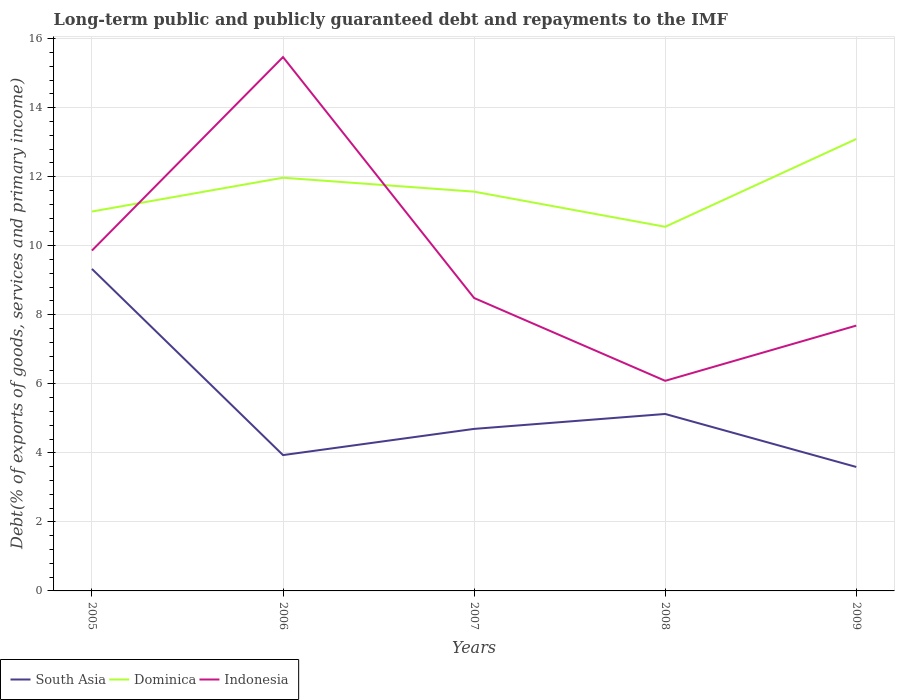How many different coloured lines are there?
Make the answer very short. 3. Does the line corresponding to Dominica intersect with the line corresponding to Indonesia?
Your answer should be compact. Yes. Is the number of lines equal to the number of legend labels?
Your response must be concise. Yes. Across all years, what is the maximum debt and repayments in South Asia?
Keep it short and to the point. 3.59. What is the total debt and repayments in Dominica in the graph?
Keep it short and to the point. -1.12. What is the difference between the highest and the second highest debt and repayments in Indonesia?
Provide a succinct answer. 9.38. How many lines are there?
Your answer should be very brief. 3. How many years are there in the graph?
Give a very brief answer. 5. What is the difference between two consecutive major ticks on the Y-axis?
Your answer should be very brief. 2. Are the values on the major ticks of Y-axis written in scientific E-notation?
Keep it short and to the point. No. How are the legend labels stacked?
Your answer should be very brief. Horizontal. What is the title of the graph?
Provide a short and direct response. Long-term public and publicly guaranteed debt and repayments to the IMF. Does "Chad" appear as one of the legend labels in the graph?
Ensure brevity in your answer.  No. What is the label or title of the X-axis?
Offer a terse response. Years. What is the label or title of the Y-axis?
Provide a short and direct response. Debt(% of exports of goods, services and primary income). What is the Debt(% of exports of goods, services and primary income) of South Asia in 2005?
Offer a terse response. 9.33. What is the Debt(% of exports of goods, services and primary income) in Dominica in 2005?
Offer a very short reply. 10.99. What is the Debt(% of exports of goods, services and primary income) in Indonesia in 2005?
Your answer should be very brief. 9.86. What is the Debt(% of exports of goods, services and primary income) in South Asia in 2006?
Provide a short and direct response. 3.94. What is the Debt(% of exports of goods, services and primary income) of Dominica in 2006?
Provide a succinct answer. 11.97. What is the Debt(% of exports of goods, services and primary income) in Indonesia in 2006?
Give a very brief answer. 15.47. What is the Debt(% of exports of goods, services and primary income) in South Asia in 2007?
Make the answer very short. 4.69. What is the Debt(% of exports of goods, services and primary income) of Dominica in 2007?
Offer a terse response. 11.57. What is the Debt(% of exports of goods, services and primary income) in Indonesia in 2007?
Provide a succinct answer. 8.49. What is the Debt(% of exports of goods, services and primary income) of South Asia in 2008?
Your response must be concise. 5.13. What is the Debt(% of exports of goods, services and primary income) of Dominica in 2008?
Give a very brief answer. 10.55. What is the Debt(% of exports of goods, services and primary income) in Indonesia in 2008?
Make the answer very short. 6.09. What is the Debt(% of exports of goods, services and primary income) of South Asia in 2009?
Make the answer very short. 3.59. What is the Debt(% of exports of goods, services and primary income) of Dominica in 2009?
Provide a succinct answer. 13.09. What is the Debt(% of exports of goods, services and primary income) in Indonesia in 2009?
Offer a very short reply. 7.69. Across all years, what is the maximum Debt(% of exports of goods, services and primary income) in South Asia?
Offer a terse response. 9.33. Across all years, what is the maximum Debt(% of exports of goods, services and primary income) of Dominica?
Provide a succinct answer. 13.09. Across all years, what is the maximum Debt(% of exports of goods, services and primary income) in Indonesia?
Offer a very short reply. 15.47. Across all years, what is the minimum Debt(% of exports of goods, services and primary income) in South Asia?
Offer a terse response. 3.59. Across all years, what is the minimum Debt(% of exports of goods, services and primary income) in Dominica?
Provide a succinct answer. 10.55. Across all years, what is the minimum Debt(% of exports of goods, services and primary income) in Indonesia?
Your response must be concise. 6.09. What is the total Debt(% of exports of goods, services and primary income) in South Asia in the graph?
Offer a terse response. 26.68. What is the total Debt(% of exports of goods, services and primary income) in Dominica in the graph?
Offer a terse response. 58.17. What is the total Debt(% of exports of goods, services and primary income) in Indonesia in the graph?
Offer a terse response. 47.59. What is the difference between the Debt(% of exports of goods, services and primary income) in South Asia in 2005 and that in 2006?
Give a very brief answer. 5.39. What is the difference between the Debt(% of exports of goods, services and primary income) in Dominica in 2005 and that in 2006?
Ensure brevity in your answer.  -0.98. What is the difference between the Debt(% of exports of goods, services and primary income) of Indonesia in 2005 and that in 2006?
Give a very brief answer. -5.61. What is the difference between the Debt(% of exports of goods, services and primary income) of South Asia in 2005 and that in 2007?
Provide a succinct answer. 4.63. What is the difference between the Debt(% of exports of goods, services and primary income) in Dominica in 2005 and that in 2007?
Provide a short and direct response. -0.58. What is the difference between the Debt(% of exports of goods, services and primary income) of Indonesia in 2005 and that in 2007?
Your response must be concise. 1.38. What is the difference between the Debt(% of exports of goods, services and primary income) in South Asia in 2005 and that in 2008?
Provide a short and direct response. 4.2. What is the difference between the Debt(% of exports of goods, services and primary income) in Dominica in 2005 and that in 2008?
Ensure brevity in your answer.  0.44. What is the difference between the Debt(% of exports of goods, services and primary income) of Indonesia in 2005 and that in 2008?
Keep it short and to the point. 3.77. What is the difference between the Debt(% of exports of goods, services and primary income) in South Asia in 2005 and that in 2009?
Your answer should be very brief. 5.74. What is the difference between the Debt(% of exports of goods, services and primary income) in Dominica in 2005 and that in 2009?
Offer a very short reply. -2.1. What is the difference between the Debt(% of exports of goods, services and primary income) of Indonesia in 2005 and that in 2009?
Provide a succinct answer. 2.17. What is the difference between the Debt(% of exports of goods, services and primary income) in South Asia in 2006 and that in 2007?
Make the answer very short. -0.76. What is the difference between the Debt(% of exports of goods, services and primary income) of Dominica in 2006 and that in 2007?
Provide a short and direct response. 0.4. What is the difference between the Debt(% of exports of goods, services and primary income) in Indonesia in 2006 and that in 2007?
Your answer should be compact. 6.98. What is the difference between the Debt(% of exports of goods, services and primary income) of South Asia in 2006 and that in 2008?
Provide a short and direct response. -1.19. What is the difference between the Debt(% of exports of goods, services and primary income) in Dominica in 2006 and that in 2008?
Keep it short and to the point. 1.42. What is the difference between the Debt(% of exports of goods, services and primary income) in Indonesia in 2006 and that in 2008?
Provide a succinct answer. 9.38. What is the difference between the Debt(% of exports of goods, services and primary income) of South Asia in 2006 and that in 2009?
Give a very brief answer. 0.34. What is the difference between the Debt(% of exports of goods, services and primary income) in Dominica in 2006 and that in 2009?
Keep it short and to the point. -1.12. What is the difference between the Debt(% of exports of goods, services and primary income) in Indonesia in 2006 and that in 2009?
Provide a short and direct response. 7.78. What is the difference between the Debt(% of exports of goods, services and primary income) of South Asia in 2007 and that in 2008?
Make the answer very short. -0.43. What is the difference between the Debt(% of exports of goods, services and primary income) of Indonesia in 2007 and that in 2008?
Offer a terse response. 2.4. What is the difference between the Debt(% of exports of goods, services and primary income) in South Asia in 2007 and that in 2009?
Give a very brief answer. 1.1. What is the difference between the Debt(% of exports of goods, services and primary income) in Dominica in 2007 and that in 2009?
Keep it short and to the point. -1.52. What is the difference between the Debt(% of exports of goods, services and primary income) of Indonesia in 2007 and that in 2009?
Provide a succinct answer. 0.8. What is the difference between the Debt(% of exports of goods, services and primary income) of South Asia in 2008 and that in 2009?
Ensure brevity in your answer.  1.53. What is the difference between the Debt(% of exports of goods, services and primary income) in Dominica in 2008 and that in 2009?
Give a very brief answer. -2.54. What is the difference between the Debt(% of exports of goods, services and primary income) of Indonesia in 2008 and that in 2009?
Keep it short and to the point. -1.6. What is the difference between the Debt(% of exports of goods, services and primary income) in South Asia in 2005 and the Debt(% of exports of goods, services and primary income) in Dominica in 2006?
Ensure brevity in your answer.  -2.64. What is the difference between the Debt(% of exports of goods, services and primary income) in South Asia in 2005 and the Debt(% of exports of goods, services and primary income) in Indonesia in 2006?
Provide a short and direct response. -6.14. What is the difference between the Debt(% of exports of goods, services and primary income) in Dominica in 2005 and the Debt(% of exports of goods, services and primary income) in Indonesia in 2006?
Provide a short and direct response. -4.47. What is the difference between the Debt(% of exports of goods, services and primary income) in South Asia in 2005 and the Debt(% of exports of goods, services and primary income) in Dominica in 2007?
Offer a very short reply. -2.24. What is the difference between the Debt(% of exports of goods, services and primary income) in South Asia in 2005 and the Debt(% of exports of goods, services and primary income) in Indonesia in 2007?
Offer a terse response. 0.84. What is the difference between the Debt(% of exports of goods, services and primary income) in Dominica in 2005 and the Debt(% of exports of goods, services and primary income) in Indonesia in 2007?
Give a very brief answer. 2.51. What is the difference between the Debt(% of exports of goods, services and primary income) in South Asia in 2005 and the Debt(% of exports of goods, services and primary income) in Dominica in 2008?
Ensure brevity in your answer.  -1.22. What is the difference between the Debt(% of exports of goods, services and primary income) of South Asia in 2005 and the Debt(% of exports of goods, services and primary income) of Indonesia in 2008?
Give a very brief answer. 3.24. What is the difference between the Debt(% of exports of goods, services and primary income) of Dominica in 2005 and the Debt(% of exports of goods, services and primary income) of Indonesia in 2008?
Provide a short and direct response. 4.9. What is the difference between the Debt(% of exports of goods, services and primary income) of South Asia in 2005 and the Debt(% of exports of goods, services and primary income) of Dominica in 2009?
Keep it short and to the point. -3.76. What is the difference between the Debt(% of exports of goods, services and primary income) in South Asia in 2005 and the Debt(% of exports of goods, services and primary income) in Indonesia in 2009?
Your answer should be very brief. 1.64. What is the difference between the Debt(% of exports of goods, services and primary income) in Dominica in 2005 and the Debt(% of exports of goods, services and primary income) in Indonesia in 2009?
Ensure brevity in your answer.  3.31. What is the difference between the Debt(% of exports of goods, services and primary income) of South Asia in 2006 and the Debt(% of exports of goods, services and primary income) of Dominica in 2007?
Provide a succinct answer. -7.63. What is the difference between the Debt(% of exports of goods, services and primary income) in South Asia in 2006 and the Debt(% of exports of goods, services and primary income) in Indonesia in 2007?
Give a very brief answer. -4.55. What is the difference between the Debt(% of exports of goods, services and primary income) in Dominica in 2006 and the Debt(% of exports of goods, services and primary income) in Indonesia in 2007?
Provide a succinct answer. 3.49. What is the difference between the Debt(% of exports of goods, services and primary income) in South Asia in 2006 and the Debt(% of exports of goods, services and primary income) in Dominica in 2008?
Your answer should be compact. -6.61. What is the difference between the Debt(% of exports of goods, services and primary income) of South Asia in 2006 and the Debt(% of exports of goods, services and primary income) of Indonesia in 2008?
Offer a very short reply. -2.15. What is the difference between the Debt(% of exports of goods, services and primary income) of Dominica in 2006 and the Debt(% of exports of goods, services and primary income) of Indonesia in 2008?
Keep it short and to the point. 5.88. What is the difference between the Debt(% of exports of goods, services and primary income) in South Asia in 2006 and the Debt(% of exports of goods, services and primary income) in Dominica in 2009?
Offer a terse response. -9.16. What is the difference between the Debt(% of exports of goods, services and primary income) in South Asia in 2006 and the Debt(% of exports of goods, services and primary income) in Indonesia in 2009?
Give a very brief answer. -3.75. What is the difference between the Debt(% of exports of goods, services and primary income) of Dominica in 2006 and the Debt(% of exports of goods, services and primary income) of Indonesia in 2009?
Your response must be concise. 4.28. What is the difference between the Debt(% of exports of goods, services and primary income) of South Asia in 2007 and the Debt(% of exports of goods, services and primary income) of Dominica in 2008?
Keep it short and to the point. -5.86. What is the difference between the Debt(% of exports of goods, services and primary income) in South Asia in 2007 and the Debt(% of exports of goods, services and primary income) in Indonesia in 2008?
Your answer should be very brief. -1.39. What is the difference between the Debt(% of exports of goods, services and primary income) in Dominica in 2007 and the Debt(% of exports of goods, services and primary income) in Indonesia in 2008?
Your answer should be very brief. 5.48. What is the difference between the Debt(% of exports of goods, services and primary income) of South Asia in 2007 and the Debt(% of exports of goods, services and primary income) of Dominica in 2009?
Make the answer very short. -8.4. What is the difference between the Debt(% of exports of goods, services and primary income) in South Asia in 2007 and the Debt(% of exports of goods, services and primary income) in Indonesia in 2009?
Ensure brevity in your answer.  -2.99. What is the difference between the Debt(% of exports of goods, services and primary income) in Dominica in 2007 and the Debt(% of exports of goods, services and primary income) in Indonesia in 2009?
Your answer should be very brief. 3.88. What is the difference between the Debt(% of exports of goods, services and primary income) of South Asia in 2008 and the Debt(% of exports of goods, services and primary income) of Dominica in 2009?
Offer a very short reply. -7.97. What is the difference between the Debt(% of exports of goods, services and primary income) of South Asia in 2008 and the Debt(% of exports of goods, services and primary income) of Indonesia in 2009?
Your response must be concise. -2.56. What is the difference between the Debt(% of exports of goods, services and primary income) in Dominica in 2008 and the Debt(% of exports of goods, services and primary income) in Indonesia in 2009?
Ensure brevity in your answer.  2.86. What is the average Debt(% of exports of goods, services and primary income) in South Asia per year?
Ensure brevity in your answer.  5.34. What is the average Debt(% of exports of goods, services and primary income) in Dominica per year?
Offer a terse response. 11.63. What is the average Debt(% of exports of goods, services and primary income) of Indonesia per year?
Offer a terse response. 9.52. In the year 2005, what is the difference between the Debt(% of exports of goods, services and primary income) in South Asia and Debt(% of exports of goods, services and primary income) in Dominica?
Offer a terse response. -1.66. In the year 2005, what is the difference between the Debt(% of exports of goods, services and primary income) in South Asia and Debt(% of exports of goods, services and primary income) in Indonesia?
Provide a short and direct response. -0.53. In the year 2005, what is the difference between the Debt(% of exports of goods, services and primary income) in Dominica and Debt(% of exports of goods, services and primary income) in Indonesia?
Provide a short and direct response. 1.13. In the year 2006, what is the difference between the Debt(% of exports of goods, services and primary income) in South Asia and Debt(% of exports of goods, services and primary income) in Dominica?
Ensure brevity in your answer.  -8.04. In the year 2006, what is the difference between the Debt(% of exports of goods, services and primary income) in South Asia and Debt(% of exports of goods, services and primary income) in Indonesia?
Your answer should be very brief. -11.53. In the year 2006, what is the difference between the Debt(% of exports of goods, services and primary income) in Dominica and Debt(% of exports of goods, services and primary income) in Indonesia?
Offer a very short reply. -3.5. In the year 2007, what is the difference between the Debt(% of exports of goods, services and primary income) of South Asia and Debt(% of exports of goods, services and primary income) of Dominica?
Offer a terse response. -6.87. In the year 2007, what is the difference between the Debt(% of exports of goods, services and primary income) of South Asia and Debt(% of exports of goods, services and primary income) of Indonesia?
Make the answer very short. -3.79. In the year 2007, what is the difference between the Debt(% of exports of goods, services and primary income) of Dominica and Debt(% of exports of goods, services and primary income) of Indonesia?
Your answer should be compact. 3.08. In the year 2008, what is the difference between the Debt(% of exports of goods, services and primary income) in South Asia and Debt(% of exports of goods, services and primary income) in Dominica?
Ensure brevity in your answer.  -5.42. In the year 2008, what is the difference between the Debt(% of exports of goods, services and primary income) in South Asia and Debt(% of exports of goods, services and primary income) in Indonesia?
Offer a terse response. -0.96. In the year 2008, what is the difference between the Debt(% of exports of goods, services and primary income) in Dominica and Debt(% of exports of goods, services and primary income) in Indonesia?
Offer a terse response. 4.46. In the year 2009, what is the difference between the Debt(% of exports of goods, services and primary income) of South Asia and Debt(% of exports of goods, services and primary income) of Dominica?
Provide a succinct answer. -9.5. In the year 2009, what is the difference between the Debt(% of exports of goods, services and primary income) of South Asia and Debt(% of exports of goods, services and primary income) of Indonesia?
Your response must be concise. -4.1. In the year 2009, what is the difference between the Debt(% of exports of goods, services and primary income) of Dominica and Debt(% of exports of goods, services and primary income) of Indonesia?
Make the answer very short. 5.41. What is the ratio of the Debt(% of exports of goods, services and primary income) in South Asia in 2005 to that in 2006?
Offer a very short reply. 2.37. What is the ratio of the Debt(% of exports of goods, services and primary income) of Dominica in 2005 to that in 2006?
Give a very brief answer. 0.92. What is the ratio of the Debt(% of exports of goods, services and primary income) of Indonesia in 2005 to that in 2006?
Provide a succinct answer. 0.64. What is the ratio of the Debt(% of exports of goods, services and primary income) of South Asia in 2005 to that in 2007?
Ensure brevity in your answer.  1.99. What is the ratio of the Debt(% of exports of goods, services and primary income) of Dominica in 2005 to that in 2007?
Keep it short and to the point. 0.95. What is the ratio of the Debt(% of exports of goods, services and primary income) in Indonesia in 2005 to that in 2007?
Provide a short and direct response. 1.16. What is the ratio of the Debt(% of exports of goods, services and primary income) in South Asia in 2005 to that in 2008?
Make the answer very short. 1.82. What is the ratio of the Debt(% of exports of goods, services and primary income) of Dominica in 2005 to that in 2008?
Ensure brevity in your answer.  1.04. What is the ratio of the Debt(% of exports of goods, services and primary income) in Indonesia in 2005 to that in 2008?
Offer a very short reply. 1.62. What is the ratio of the Debt(% of exports of goods, services and primary income) in South Asia in 2005 to that in 2009?
Offer a terse response. 2.6. What is the ratio of the Debt(% of exports of goods, services and primary income) in Dominica in 2005 to that in 2009?
Make the answer very short. 0.84. What is the ratio of the Debt(% of exports of goods, services and primary income) in Indonesia in 2005 to that in 2009?
Your response must be concise. 1.28. What is the ratio of the Debt(% of exports of goods, services and primary income) in South Asia in 2006 to that in 2007?
Ensure brevity in your answer.  0.84. What is the ratio of the Debt(% of exports of goods, services and primary income) of Dominica in 2006 to that in 2007?
Provide a short and direct response. 1.03. What is the ratio of the Debt(% of exports of goods, services and primary income) in Indonesia in 2006 to that in 2007?
Offer a very short reply. 1.82. What is the ratio of the Debt(% of exports of goods, services and primary income) of South Asia in 2006 to that in 2008?
Your response must be concise. 0.77. What is the ratio of the Debt(% of exports of goods, services and primary income) of Dominica in 2006 to that in 2008?
Offer a very short reply. 1.13. What is the ratio of the Debt(% of exports of goods, services and primary income) of Indonesia in 2006 to that in 2008?
Offer a very short reply. 2.54. What is the ratio of the Debt(% of exports of goods, services and primary income) of South Asia in 2006 to that in 2009?
Your response must be concise. 1.1. What is the ratio of the Debt(% of exports of goods, services and primary income) in Dominica in 2006 to that in 2009?
Give a very brief answer. 0.91. What is the ratio of the Debt(% of exports of goods, services and primary income) in Indonesia in 2006 to that in 2009?
Keep it short and to the point. 2.01. What is the ratio of the Debt(% of exports of goods, services and primary income) in South Asia in 2007 to that in 2008?
Provide a short and direct response. 0.92. What is the ratio of the Debt(% of exports of goods, services and primary income) in Dominica in 2007 to that in 2008?
Make the answer very short. 1.1. What is the ratio of the Debt(% of exports of goods, services and primary income) in Indonesia in 2007 to that in 2008?
Make the answer very short. 1.39. What is the ratio of the Debt(% of exports of goods, services and primary income) of South Asia in 2007 to that in 2009?
Give a very brief answer. 1.31. What is the ratio of the Debt(% of exports of goods, services and primary income) of Dominica in 2007 to that in 2009?
Your answer should be compact. 0.88. What is the ratio of the Debt(% of exports of goods, services and primary income) of Indonesia in 2007 to that in 2009?
Provide a short and direct response. 1.1. What is the ratio of the Debt(% of exports of goods, services and primary income) in South Asia in 2008 to that in 2009?
Provide a succinct answer. 1.43. What is the ratio of the Debt(% of exports of goods, services and primary income) in Dominica in 2008 to that in 2009?
Your answer should be compact. 0.81. What is the ratio of the Debt(% of exports of goods, services and primary income) in Indonesia in 2008 to that in 2009?
Offer a very short reply. 0.79. What is the difference between the highest and the second highest Debt(% of exports of goods, services and primary income) in South Asia?
Give a very brief answer. 4.2. What is the difference between the highest and the second highest Debt(% of exports of goods, services and primary income) in Dominica?
Offer a very short reply. 1.12. What is the difference between the highest and the second highest Debt(% of exports of goods, services and primary income) of Indonesia?
Your answer should be compact. 5.61. What is the difference between the highest and the lowest Debt(% of exports of goods, services and primary income) in South Asia?
Give a very brief answer. 5.74. What is the difference between the highest and the lowest Debt(% of exports of goods, services and primary income) of Dominica?
Offer a very short reply. 2.54. What is the difference between the highest and the lowest Debt(% of exports of goods, services and primary income) of Indonesia?
Give a very brief answer. 9.38. 